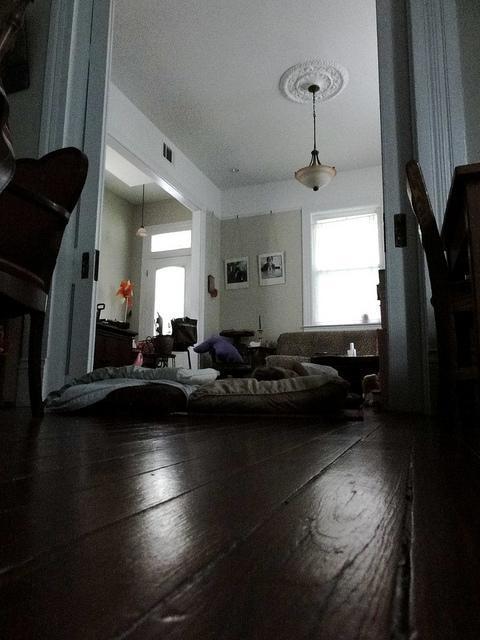How many pictures are hanging on the wall?
Give a very brief answer. 2. How many chairs are there?
Give a very brief answer. 2. How many hats is the man wearing?
Give a very brief answer. 0. 